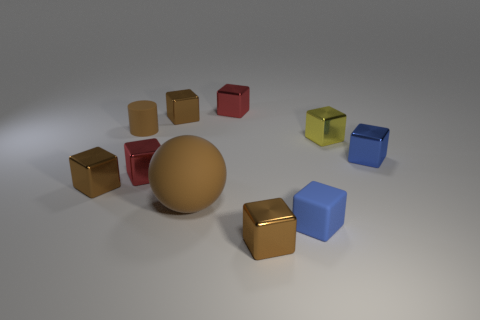Subtract all brown cylinders. How many brown cubes are left? 3 Subtract 1 blocks. How many blocks are left? 7 Subtract all brown blocks. How many blocks are left? 5 Subtract all yellow metallic blocks. How many blocks are left? 7 Subtract all purple blocks. Subtract all gray spheres. How many blocks are left? 8 Subtract all cylinders. How many objects are left? 9 Subtract all red metal cubes. Subtract all red metal things. How many objects are left? 6 Add 9 blue rubber things. How many blue rubber things are left? 10 Add 7 large cubes. How many large cubes exist? 7 Subtract 0 purple cylinders. How many objects are left? 10 